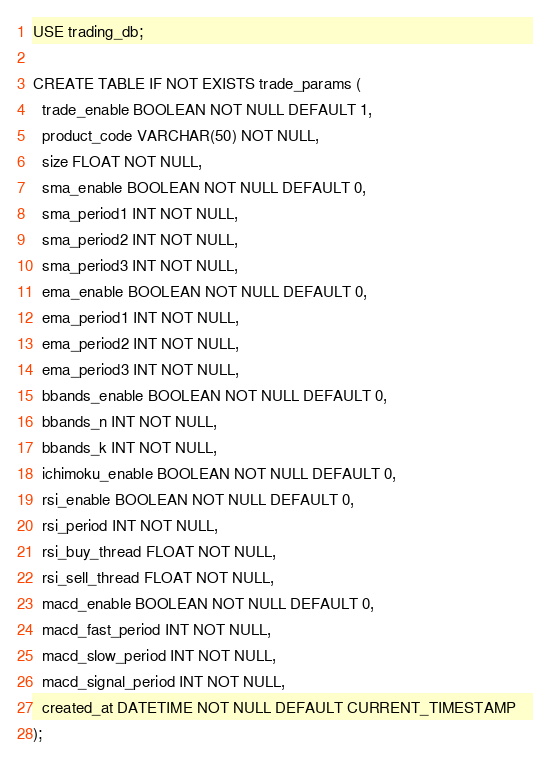<code> <loc_0><loc_0><loc_500><loc_500><_SQL_>USE trading_db;

CREATE TABLE IF NOT EXISTS trade_params (
  trade_enable BOOLEAN NOT NULL DEFAULT 1,
  product_code VARCHAR(50) NOT NULL,
  size FLOAT NOT NULL,
  sma_enable BOOLEAN NOT NULL DEFAULT 0,
  sma_period1 INT NOT NULL,
  sma_period2 INT NOT NULL,
  sma_period3 INT NOT NULL,
  ema_enable BOOLEAN NOT NULL DEFAULT 0,
  ema_period1 INT NOT NULL,
  ema_period2 INT NOT NULL,
  ema_period3 INT NOT NULL,
  bbands_enable BOOLEAN NOT NULL DEFAULT 0,
  bbands_n INT NOT NULL,
  bbands_k INT NOT NULL,
  ichimoku_enable BOOLEAN NOT NULL DEFAULT 0,
  rsi_enable BOOLEAN NOT NULL DEFAULT 0,
  rsi_period INT NOT NULL,
  rsi_buy_thread FLOAT NOT NULL,
  rsi_sell_thread FLOAT NOT NULL,
  macd_enable BOOLEAN NOT NULL DEFAULT 0,
  macd_fast_period INT NOT NULL,
  macd_slow_period INT NOT NULL,
  macd_signal_period INT NOT NULL,
  created_at DATETIME NOT NULL DEFAULT CURRENT_TIMESTAMP
);
</code> 